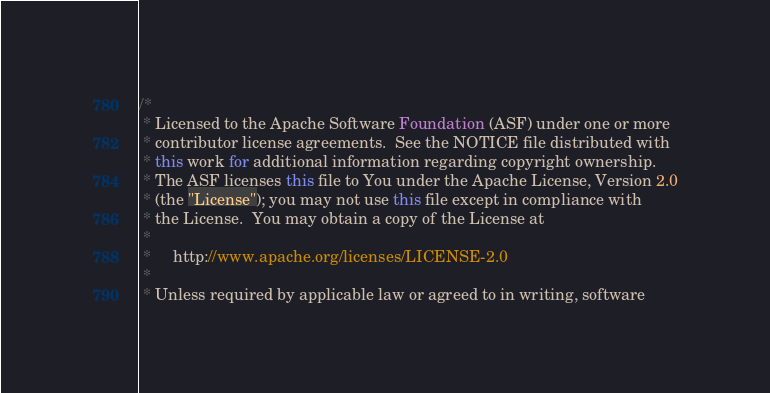Convert code to text. <code><loc_0><loc_0><loc_500><loc_500><_Java_>/*
 * Licensed to the Apache Software Foundation (ASF) under one or more
 * contributor license agreements.  See the NOTICE file distributed with
 * this work for additional information regarding copyright ownership.
 * The ASF licenses this file to You under the Apache License, Version 2.0
 * (the "License"); you may not use this file except in compliance with
 * the License.  You may obtain a copy of the License at
 *
 *     http://www.apache.org/licenses/LICENSE-2.0
 *
 * Unless required by applicable law or agreed to in writing, software</code> 